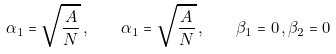Convert formula to latex. <formula><loc_0><loc_0><loc_500><loc_500>\alpha _ { 1 } = \sqrt { \frac { A } { N } } \, , \quad \alpha _ { 1 } = \sqrt { \frac { A } { N } } \, , \quad \beta _ { 1 } = 0 \, , \beta _ { 2 } = 0</formula> 